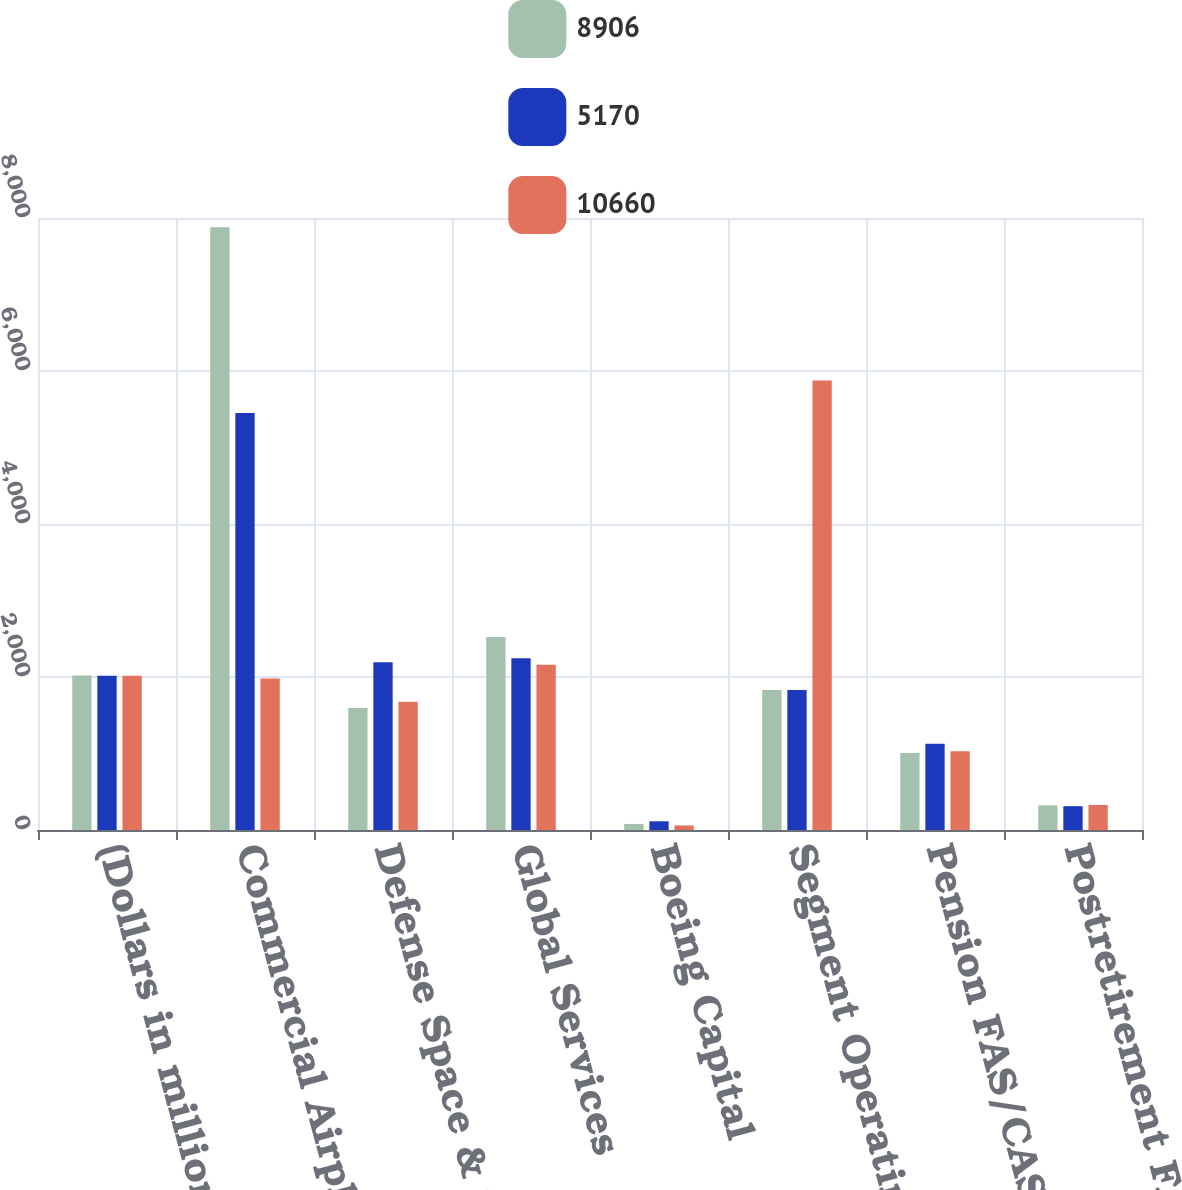Convert chart to OTSL. <chart><loc_0><loc_0><loc_500><loc_500><stacked_bar_chart><ecel><fcel>(Dollars in millions) Years<fcel>Commercial Airplanes<fcel>Defense Space & Security<fcel>Global Services<fcel>Boeing Capital<fcel>Segment Operating Profit<fcel>Pension FAS/CAS service cost<fcel>Postretirement FAS/CAS service<nl><fcel>8906<fcel>2018<fcel>7879<fcel>1594<fcel>2522<fcel>79<fcel>1829.5<fcel>1005<fcel>322<nl><fcel>5170<fcel>2017<fcel>5452<fcel>2193<fcel>2246<fcel>114<fcel>1829.5<fcel>1127<fcel>311<nl><fcel>10660<fcel>2016<fcel>1981<fcel>1678<fcel>2159<fcel>59<fcel>5877<fcel>1029<fcel>328<nl></chart> 